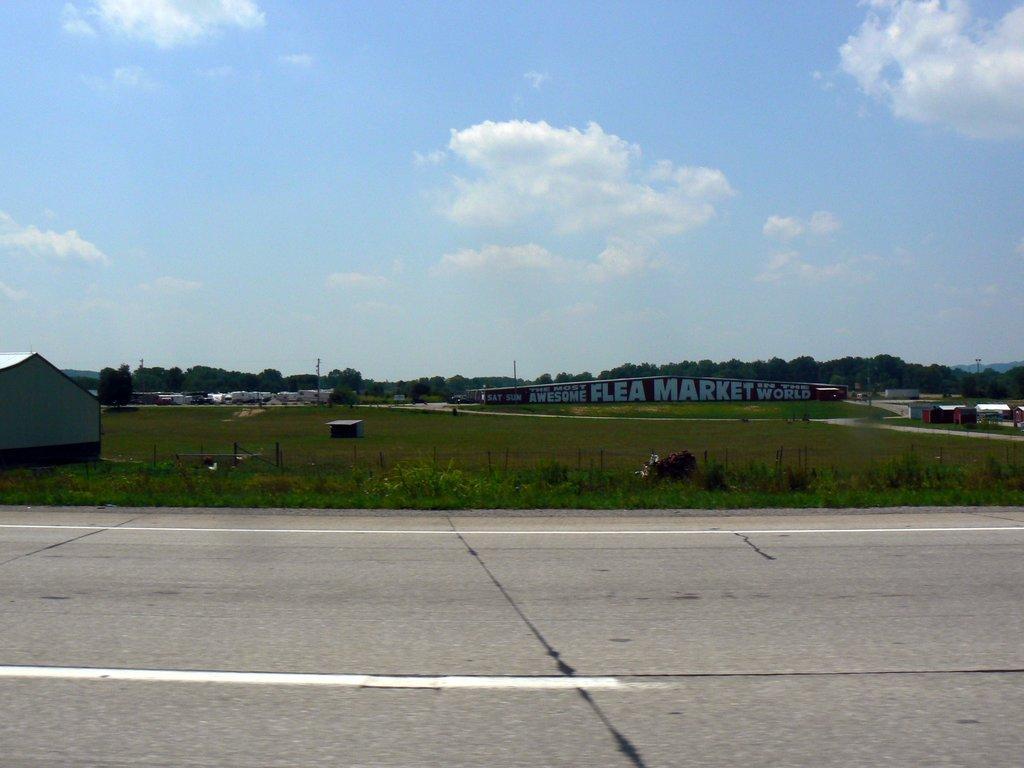Please provide a concise description of this image. In this image we can see sky with clouds, trees, poles, sheds, buildings, grass and road. 